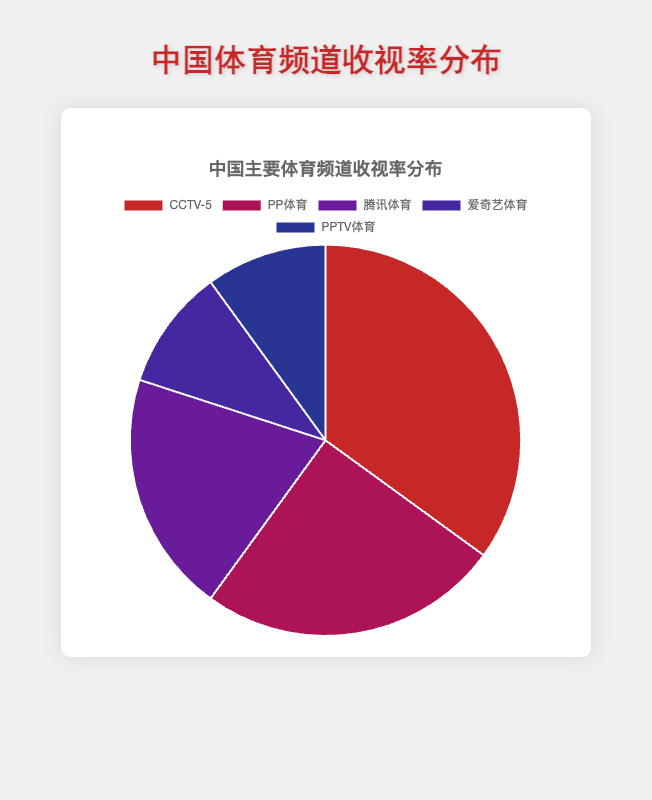哪种体育频道有最多的收视率？ 在图表中，最大的那部分是红色的，它代表的是CCTV-5，占据35%的收视率。
Answer: CCTV-5 爱奇艺体育和PPTV体育的收视率总和是多少？ 爱奇艺体育和PPTV体育的收视率分别是10%和10%，相加起来是10% + 10% = 20%。
Answer: 20% PP体育的收视率比腾讯体育高多少？ PP体育的收视率是25%，而腾讯体育是20%。25% - 20% = 5%。
Answer: 5% 收视率第二高的体育频道是什么？ 图表中显示第二大部分是紫红色的，它代表的是PP体育，有25%的收视率。
Answer: PP体育 CCTV-5的收视率占总和的比例是其他频道总和的几倍？ CCTV-5的收视率是35%。其他频道的总和是25% + 20% + 10% + 10% = 65%。35%相对于65%的等比是35 / 65 = 0.538，约为0.54倍。
Answer: 0.54倍 